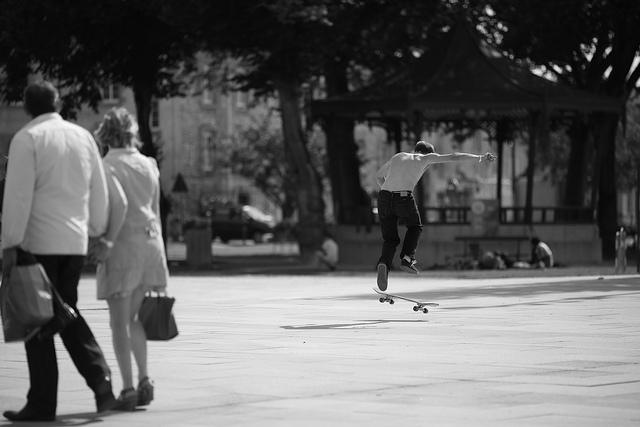How many skateboards are in the picture?
Give a very brief answer. 1. Which man is wearing a white coat?
Quick response, please. Left. What sport is the boy engaging in?
Give a very brief answer. Skateboarding. What color is the man's coat?
Give a very brief answer. White. What are the man and woman on the left doing?
Keep it brief. Walking. What is the woman carrying?
Short answer required. Purse. What are the two people holding in their hands?
Write a very short answer. Bags. What are the people looking at?
Be succinct. Skateboarder. What season is it?
Be succinct. Fall. How many people are in the picture?
Be succinct. 3. What kind of trick is this guy doing?
Answer briefly. Skateboard. 